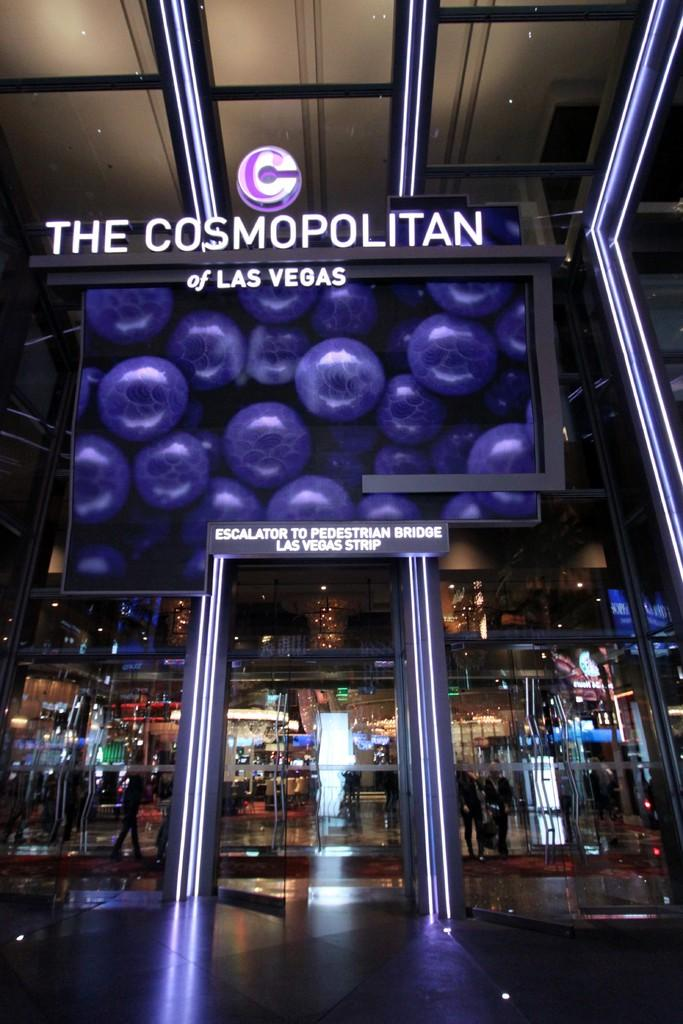<image>
Create a compact narrative representing the image presented. The Cosmopolitan of Las Vegas attraction that has a sign saying Escalator to Pedestrian Bridge Las Vegas Strip. 